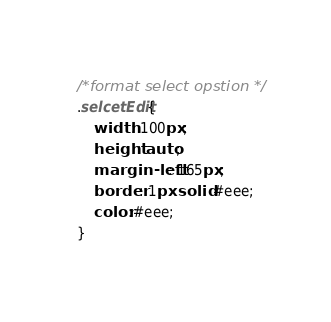Convert code to text. <code><loc_0><loc_0><loc_500><loc_500><_CSS_>/*format select opstion */
.selcetEdit{
	width: 100px;
	height: auto;
	margin-left: 165px;
	border: 1px solid #eee;
	color:#eee;
}</code> 